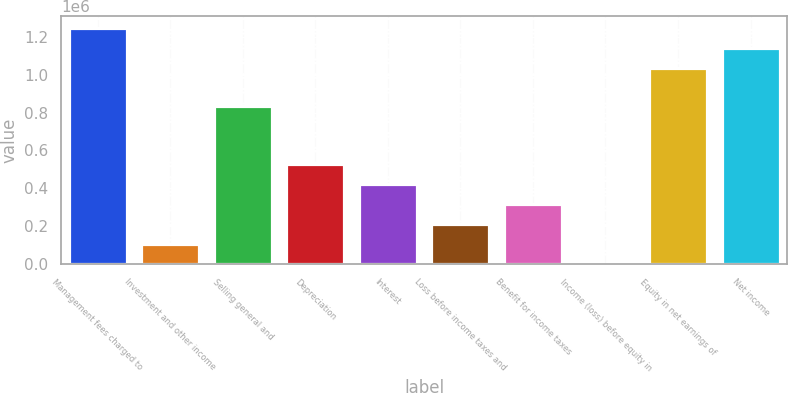Convert chart. <chart><loc_0><loc_0><loc_500><loc_500><bar_chart><fcel>Management fees charged to<fcel>Investment and other income<fcel>Selling general and<fcel>Depreciation<fcel>Interest<fcel>Loss before income taxes and<fcel>Benefit for income taxes<fcel>Income (loss) before equity in<fcel>Equity in net earnings of<fcel>Net income<nl><fcel>1.24759e+06<fcel>108361<fcel>836005<fcel>530060<fcel>424636<fcel>213786<fcel>319211<fcel>2936<fcel>1.03674e+06<fcel>1.14216e+06<nl></chart> 